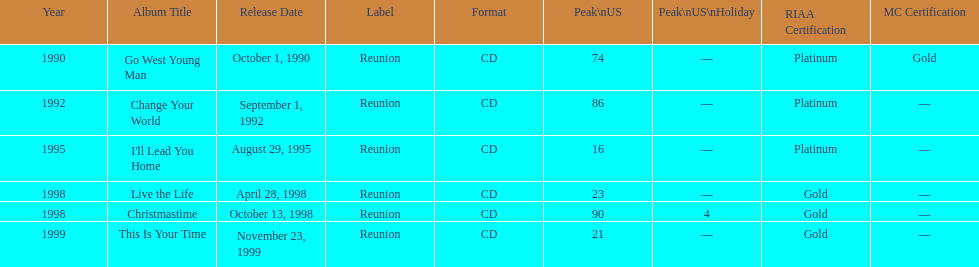What was the first michael w smith album? Go West Young Man. 